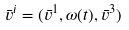Convert formula to latex. <formula><loc_0><loc_0><loc_500><loc_500>\bar { v } ^ { i } = ( \bar { v } ^ { 1 } , \omega ( t ) , \bar { v } ^ { 3 } )</formula> 